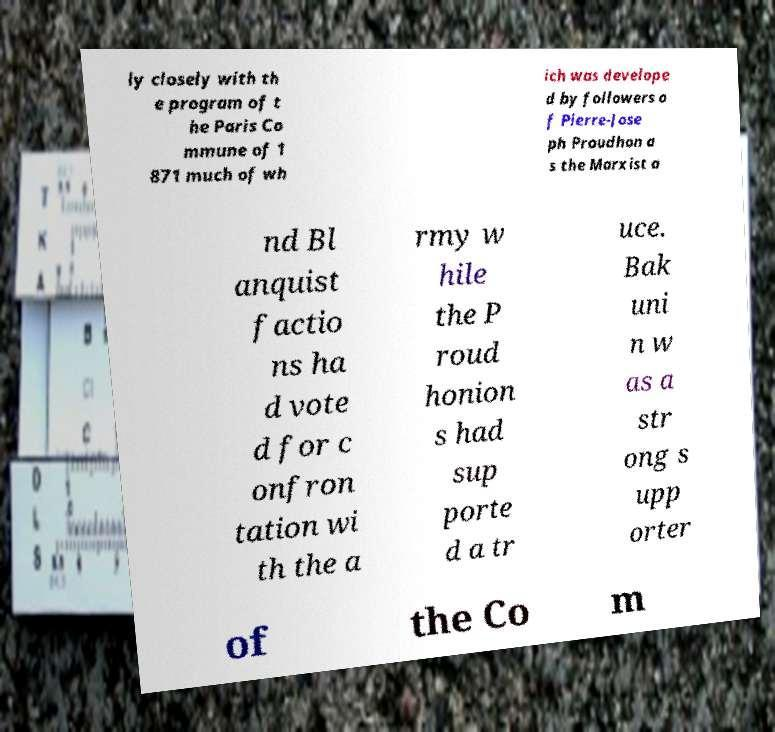I need the written content from this picture converted into text. Can you do that? ly closely with th e program of t he Paris Co mmune of 1 871 much of wh ich was develope d by followers o f Pierre-Jose ph Proudhon a s the Marxist a nd Bl anquist factio ns ha d vote d for c onfron tation wi th the a rmy w hile the P roud honion s had sup porte d a tr uce. Bak uni n w as a str ong s upp orter of the Co m 